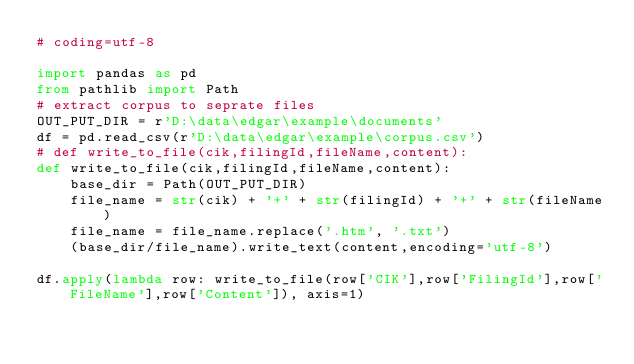Convert code to text. <code><loc_0><loc_0><loc_500><loc_500><_Python_># coding=utf-8

import pandas as pd
from pathlib import Path
# extract corpus to seprate files
OUT_PUT_DIR = r'D:\data\edgar\example\documents'
df = pd.read_csv(r'D:\data\edgar\example\corpus.csv')
# def write_to_file(cik,filingId,fileName,content):
def write_to_file(cik,filingId,fileName,content):
    base_dir = Path(OUT_PUT_DIR)
    file_name = str(cik) + '+' + str(filingId) + '+' + str(fileName)
    file_name = file_name.replace('.htm', '.txt')
    (base_dir/file_name).write_text(content,encoding='utf-8')

df.apply(lambda row: write_to_file(row['CIK'],row['FilingId'],row['FileName'],row['Content']), axis=1)
</code> 